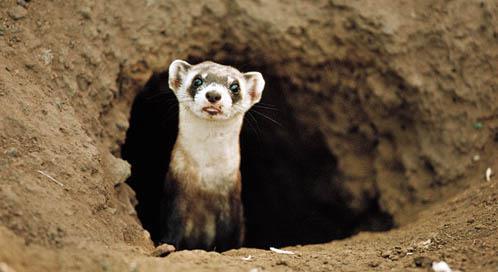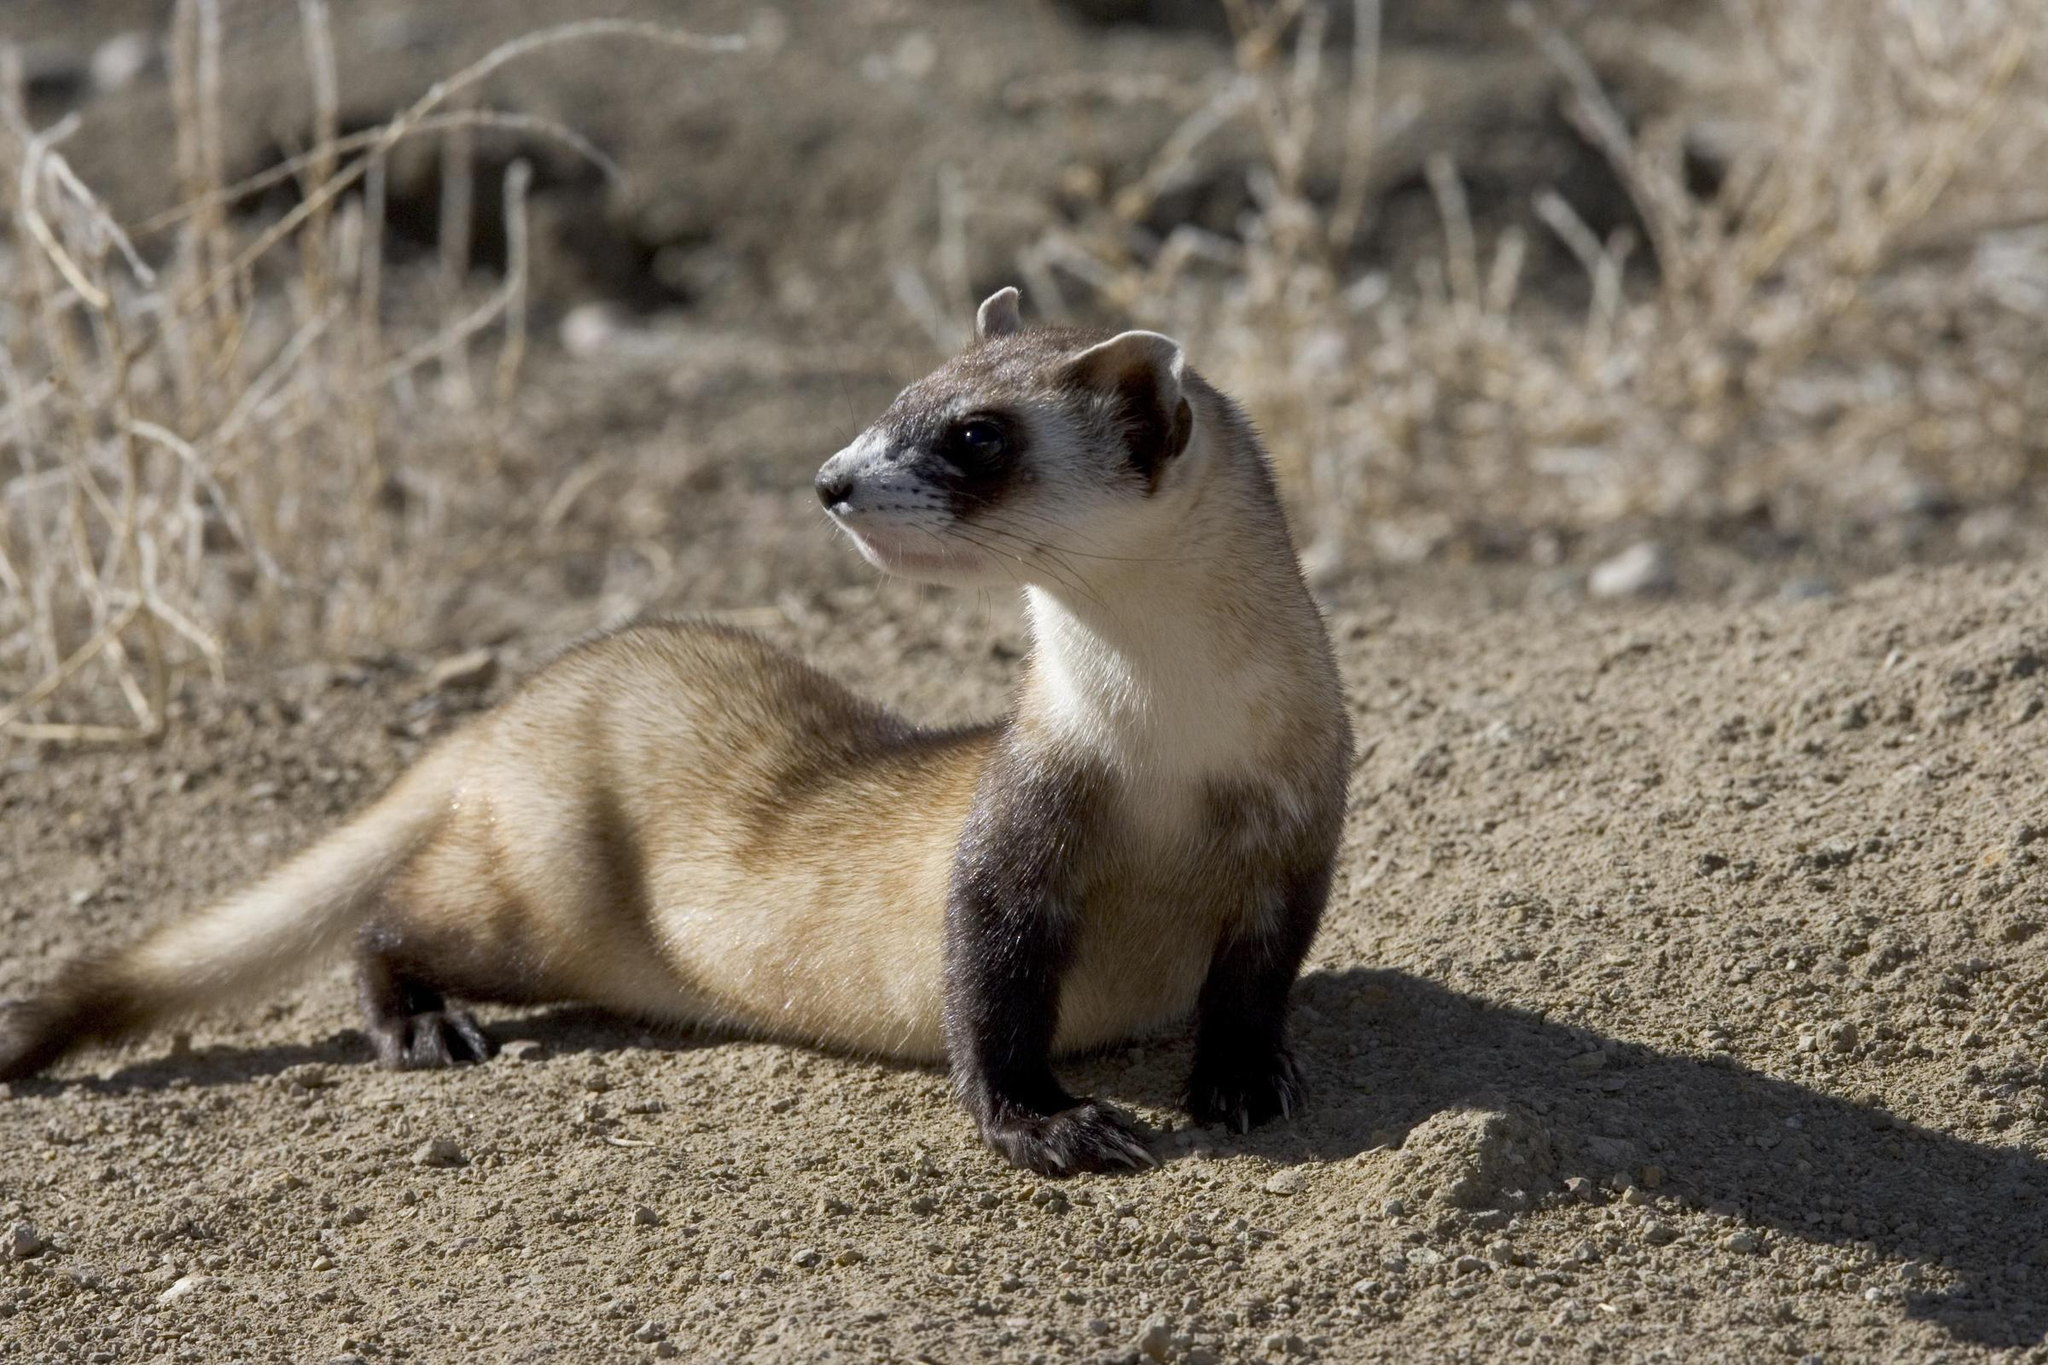The first image is the image on the left, the second image is the image on the right. Considering the images on both sides, is "A single animal is poking its head out from the ground." valid? Answer yes or no. Yes. 